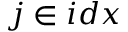Convert formula to latex. <formula><loc_0><loc_0><loc_500><loc_500>j \in i d x</formula> 